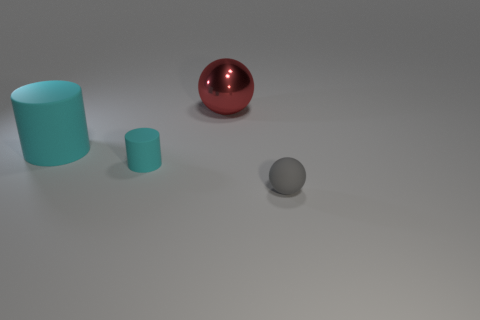What might be the function of these objects if they were in a real-world setting? The objects in the image seem to be simplistic representations without complex features, suggesting they may be used for educational purposes such as teaching geometry or for aesthetic displays due to their distinct shapes and finishes.  How do the textures of the objects differ? The textures in this image exhibit variation; the red sphere has a reflective glossy finish, indicating smoothness, whereas both the grey ball and the cyan cylinder have a matte finish, which suggests they have a more diffuse, non-reflective surface that is likely intended to scatter light evenly. 